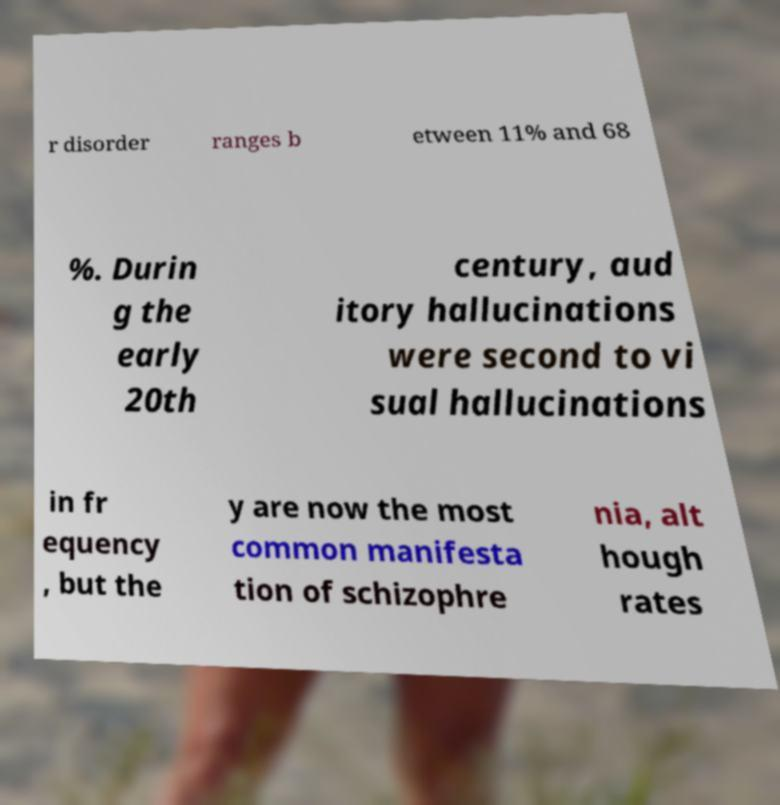Can you accurately transcribe the text from the provided image for me? r disorder ranges b etween 11% and 68 %. Durin g the early 20th century, aud itory hallucinations were second to vi sual hallucinations in fr equency , but the y are now the most common manifesta tion of schizophre nia, alt hough rates 